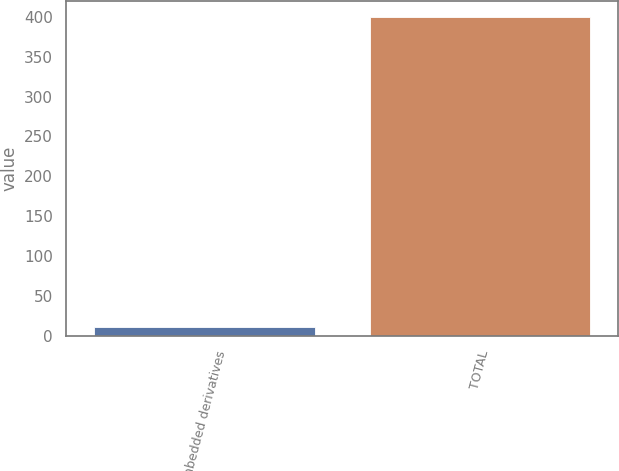Convert chart to OTSL. <chart><loc_0><loc_0><loc_500><loc_500><bar_chart><fcel>Embedded derivatives<fcel>TOTAL<nl><fcel>11<fcel>400<nl></chart> 